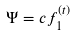<formula> <loc_0><loc_0><loc_500><loc_500>\Psi = c f _ { 1 } ^ { ( t ) }</formula> 